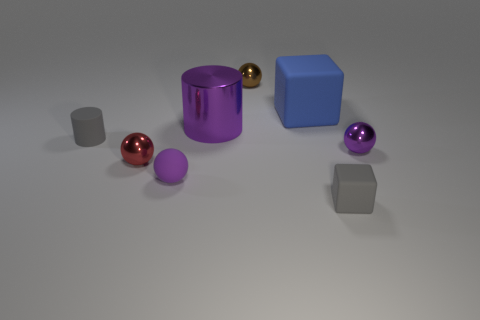Is there any other thing that is the same color as the big cube?
Offer a very short reply. No. Are there fewer small brown balls right of the big blue object than large green shiny balls?
Your answer should be compact. No. How many other purple shiny cylinders have the same size as the metal cylinder?
Offer a terse response. 0. What shape is the tiny matte thing that is the same color as the small rubber block?
Your response must be concise. Cylinder. The small rubber object right of the purple metallic thing that is to the left of the tiny gray matte thing right of the small red metallic ball is what shape?
Your answer should be very brief. Cube. There is a block behind the metal cylinder; what color is it?
Your response must be concise. Blue. How many objects are either metal balls right of the purple matte sphere or small spheres that are in front of the blue block?
Make the answer very short. 4. How many brown metallic objects are the same shape as the red metallic thing?
Provide a succinct answer. 1. What is the color of the rubber ball that is the same size as the gray matte cylinder?
Your response must be concise. Purple. What is the color of the block that is in front of the ball to the right of the matte cube in front of the small red object?
Your response must be concise. Gray. 